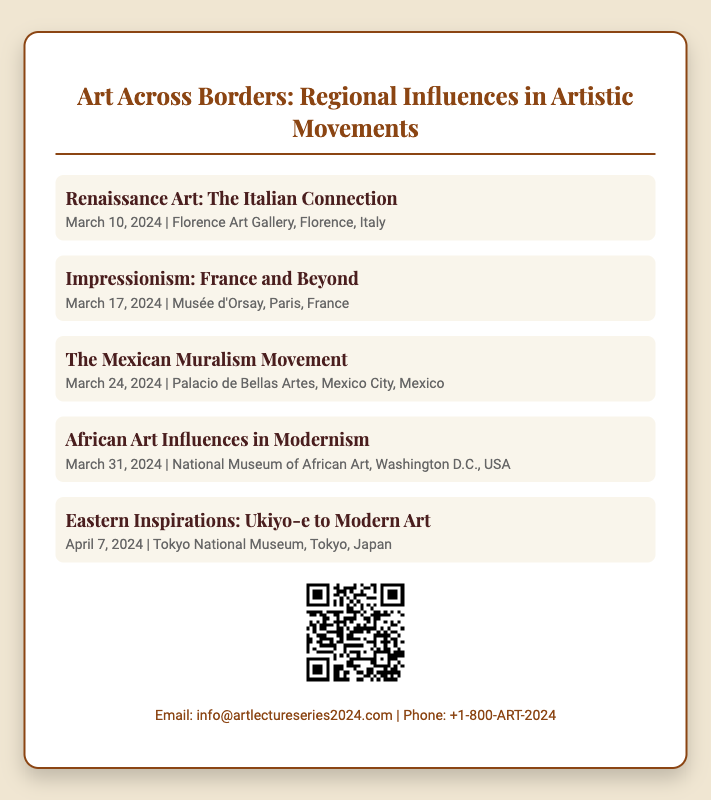What is the title of the lecture series? The title is prominently displayed at the top of the card.
Answer: Art Across Borders: Regional Influences in Artistic Movements When is the lecture on Impressionism? The date for this lecture is provided under its title.
Answer: March 17, 2024 Where is the lecture on The Mexican Muralism Movement held? The location is specified alongside the date for this lecture.
Answer: Palacio de Bellas Artes, Mexico City, Mexico How many lectures are featured in the series? The card lists all the lectures provided in the sections.
Answer: Five Who is the contact email for more information? The email address is given in the contact information section at the bottom of the card.
Answer: info@artlectureseries2024.com Which lecture is scheduled for April? The specific month for this lecture is mentioned.
Answer: Eastern Inspirations: Ukiyo-e to Modern Art What type of code is included on the card? The code is intended for scanning to obtain more information about the event.
Answer: QR Code Which museum hosts the lecture on African Art Influences in Modernism? The museum hosting this lecture is listed next to its title and date.
Answer: National Museum of African Art What font is used for the main title? The font for the title is mentioned in the style section.
Answer: Playfair Display 